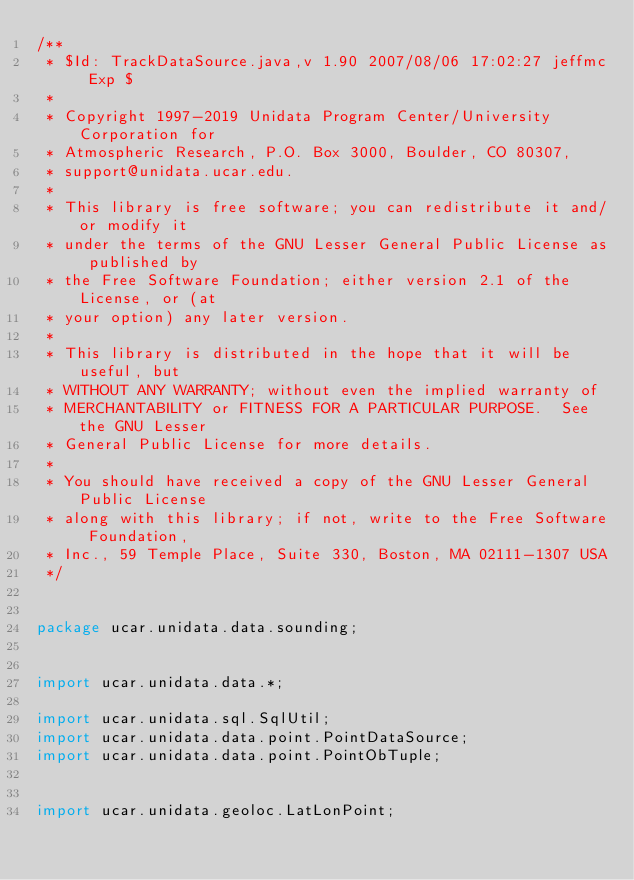<code> <loc_0><loc_0><loc_500><loc_500><_Java_>/**
 * $Id: TrackDataSource.java,v 1.90 2007/08/06 17:02:27 jeffmc Exp $
 *
 * Copyright 1997-2019 Unidata Program Center/University Corporation for
 * Atmospheric Research, P.O. Box 3000, Boulder, CO 80307,
 * support@unidata.ucar.edu.
 *
 * This library is free software; you can redistribute it and/or modify it
 * under the terms of the GNU Lesser General Public License as published by
 * the Free Software Foundation; either version 2.1 of the License, or (at
 * your option) any later version.
 *
 * This library is distributed in the hope that it will be useful, but
 * WITHOUT ANY WARRANTY; without even the implied warranty of
 * MERCHANTABILITY or FITNESS FOR A PARTICULAR PURPOSE.  See the GNU Lesser
 * General Public License for more details.
 *
 * You should have received a copy of the GNU Lesser General Public License
 * along with this library; if not, write to the Free Software Foundation,
 * Inc., 59 Temple Place, Suite 330, Boston, MA 02111-1307 USA
 */


package ucar.unidata.data.sounding;


import ucar.unidata.data.*;

import ucar.unidata.sql.SqlUtil;
import ucar.unidata.data.point.PointDataSource;
import ucar.unidata.data.point.PointObTuple;


import ucar.unidata.geoloc.LatLonPoint;</code> 